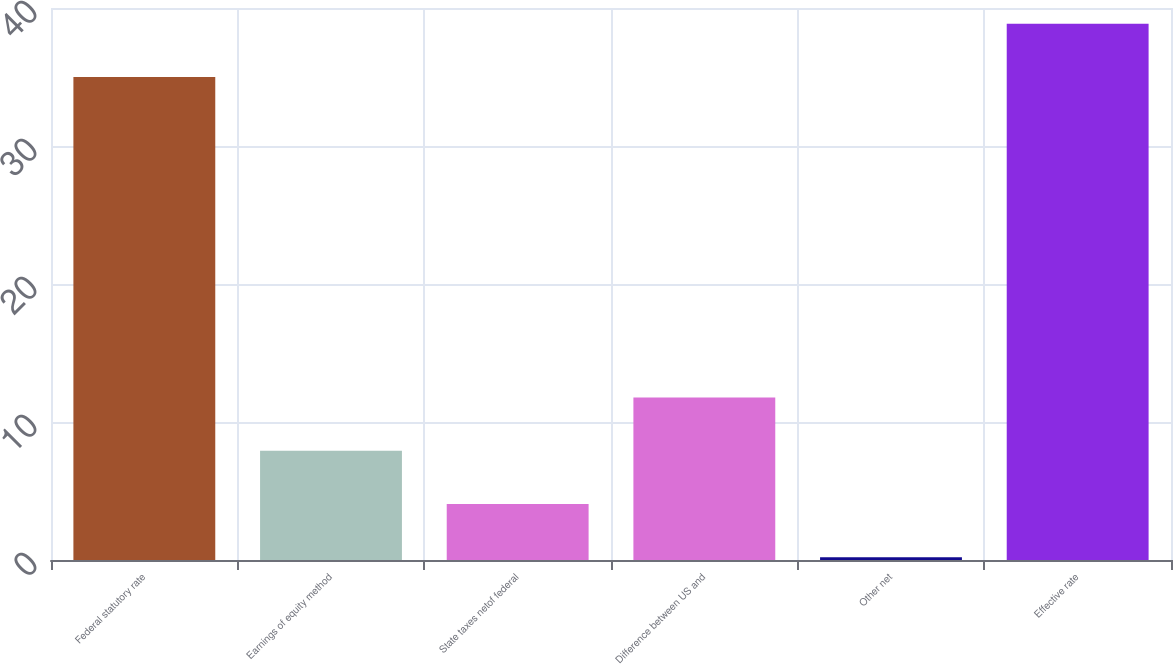<chart> <loc_0><loc_0><loc_500><loc_500><bar_chart><fcel>Federal statutory rate<fcel>Earnings of equity method<fcel>State taxes netof federal<fcel>Difference between US and<fcel>Other net<fcel>Effective rate<nl><fcel>35<fcel>7.92<fcel>4.06<fcel>11.78<fcel>0.2<fcel>38.86<nl></chart> 